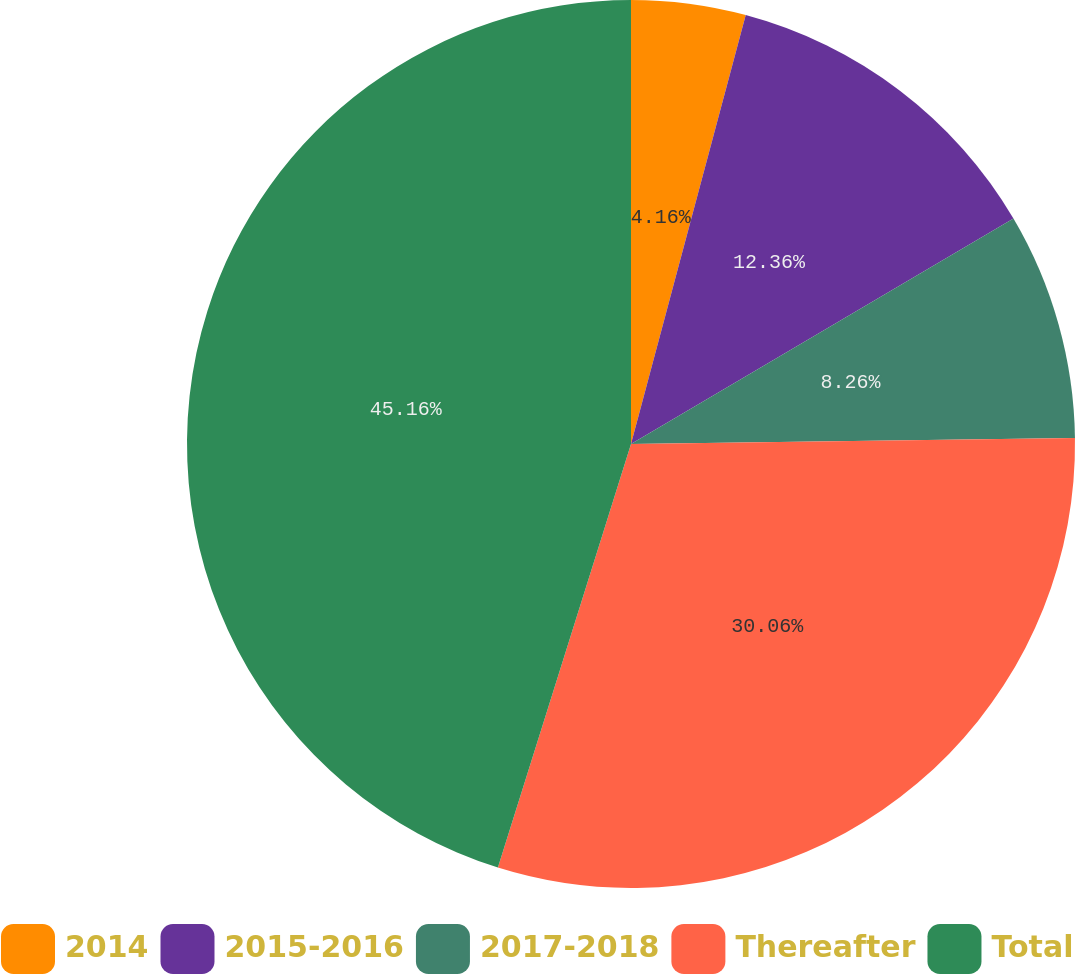Convert chart to OTSL. <chart><loc_0><loc_0><loc_500><loc_500><pie_chart><fcel>2014<fcel>2015-2016<fcel>2017-2018<fcel>Thereafter<fcel>Total<nl><fcel>4.16%<fcel>12.36%<fcel>8.26%<fcel>30.06%<fcel>45.15%<nl></chart> 